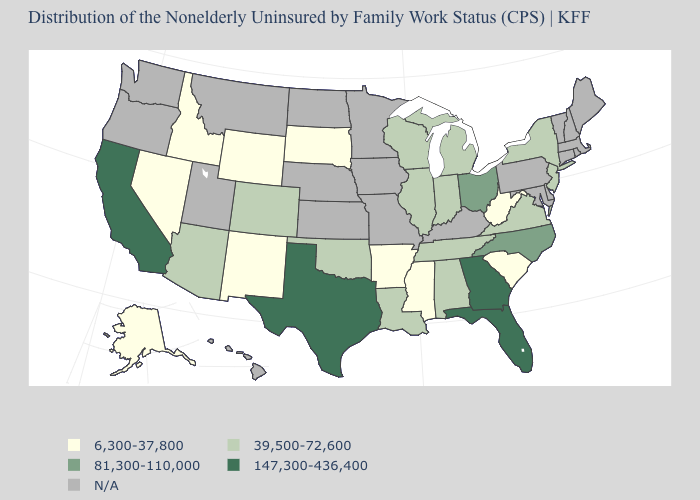What is the value of West Virginia?
Answer briefly. 6,300-37,800. What is the value of Rhode Island?
Write a very short answer. N/A. What is the highest value in the USA?
Concise answer only. 147,300-436,400. Among the states that border Wisconsin , which have the highest value?
Short answer required. Illinois, Michigan. Which states have the lowest value in the USA?
Keep it brief. Alaska, Arkansas, Idaho, Mississippi, Nevada, New Mexico, South Carolina, South Dakota, West Virginia, Wyoming. Is the legend a continuous bar?
Quick response, please. No. Among the states that border West Virginia , which have the lowest value?
Write a very short answer. Virginia. What is the value of Iowa?
Answer briefly. N/A. Among the states that border Massachusetts , which have the highest value?
Short answer required. New York. Which states have the lowest value in the USA?
Give a very brief answer. Alaska, Arkansas, Idaho, Mississippi, Nevada, New Mexico, South Carolina, South Dakota, West Virginia, Wyoming. What is the value of Massachusetts?
Quick response, please. N/A. Name the states that have a value in the range 147,300-436,400?
Keep it brief. California, Florida, Georgia, Texas. Name the states that have a value in the range 147,300-436,400?
Quick response, please. California, Florida, Georgia, Texas. Which states hav the highest value in the South?
Concise answer only. Florida, Georgia, Texas. 